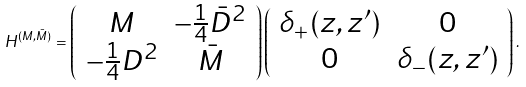Convert formula to latex. <formula><loc_0><loc_0><loc_500><loc_500>H ^ { ( M , \bar { M } ) } = \left ( \begin{array} { c c } M & - \frac { 1 } { 4 } \bar { D } ^ { 2 } \\ - \frac { 1 } { 4 } D ^ { 2 } & \bar { M } \end{array} \right ) \left ( \begin{array} { c c } \delta _ { + } ( z , z ^ { \prime } ) & 0 \\ 0 & \delta _ { - } ( z , z ^ { \prime } ) \end{array} \right ) .</formula> 